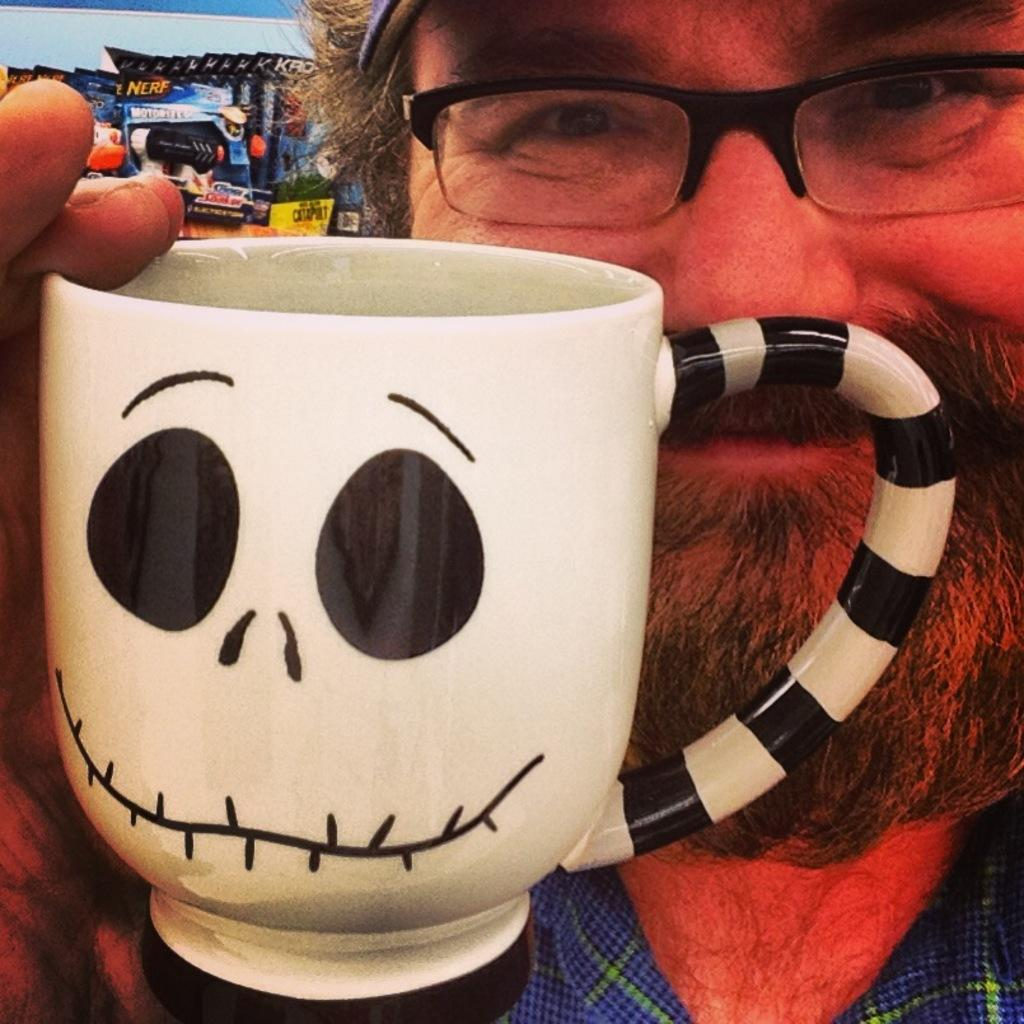What is the man in the image holding? The man is holding a cup in the image. What can be seen on the cup? There is a picture on the cup. What objects are visible in the background of the image? There are toy boxes in the background of the image. What accessory is the man wearing? The man is wearing spectacles. What type of milk is being poured into the cup in the image? There is no milk being poured into the cup in the image; the man is simply holding a cup with a picture on it. 